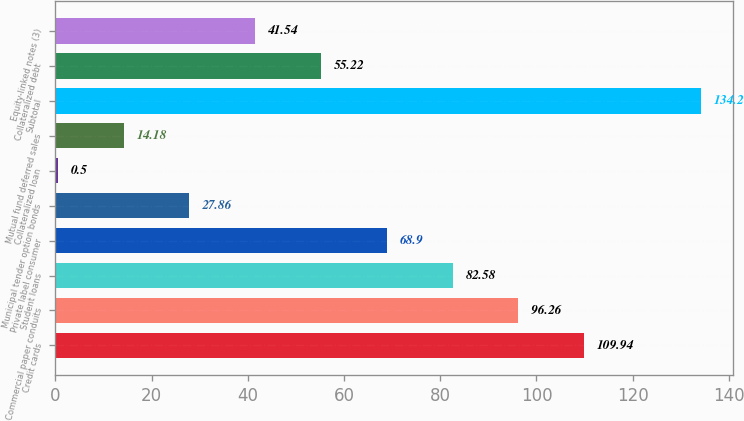Convert chart to OTSL. <chart><loc_0><loc_0><loc_500><loc_500><bar_chart><fcel>Credit cards<fcel>Commercial paper conduits<fcel>Student loans<fcel>Private label consumer<fcel>Municipal tender option bonds<fcel>Collateralized loan<fcel>Mutual fund deferred sales<fcel>Subtotal<fcel>Collateralized debt<fcel>Equity-linked notes (3)<nl><fcel>109.94<fcel>96.26<fcel>82.58<fcel>68.9<fcel>27.86<fcel>0.5<fcel>14.18<fcel>134.2<fcel>55.22<fcel>41.54<nl></chart> 